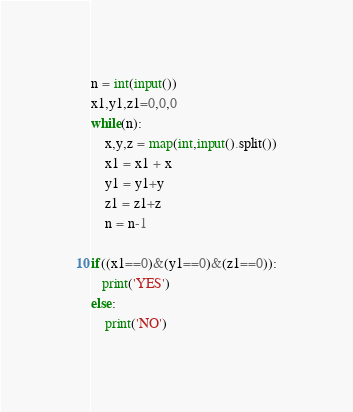<code> <loc_0><loc_0><loc_500><loc_500><_Python_>n = int(input())
x1,y1,z1=0,0,0
while(n):
    x,y,z = map(int,input().split())
    x1 = x1 + x
    y1 = y1+y
    z1 = z1+z
    n = n-1 

if((x1==0)&(y1==0)&(z1==0)):
   print('YES')
else:
    print('NO')</code> 